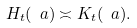<formula> <loc_0><loc_0><loc_500><loc_500>H _ { t } ( \ a ) \asymp K _ { t } ( \ a ) .</formula> 